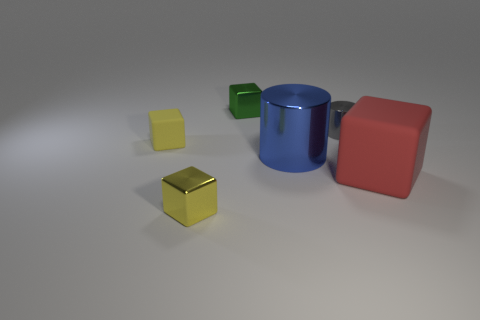Subtract all small cubes. How many cubes are left? 1 Subtract 2 cubes. How many cubes are left? 2 Add 1 large yellow metallic cylinders. How many objects exist? 7 Subtract all cylinders. How many objects are left? 4 Subtract all purple cubes. Subtract all cyan cylinders. How many cubes are left? 4 Subtract all blue balls. How many gray cubes are left? 0 Subtract all small gray metallic cylinders. Subtract all purple rubber balls. How many objects are left? 5 Add 5 yellow blocks. How many yellow blocks are left? 7 Add 6 large red objects. How many large red objects exist? 7 Subtract all gray cylinders. How many cylinders are left? 1 